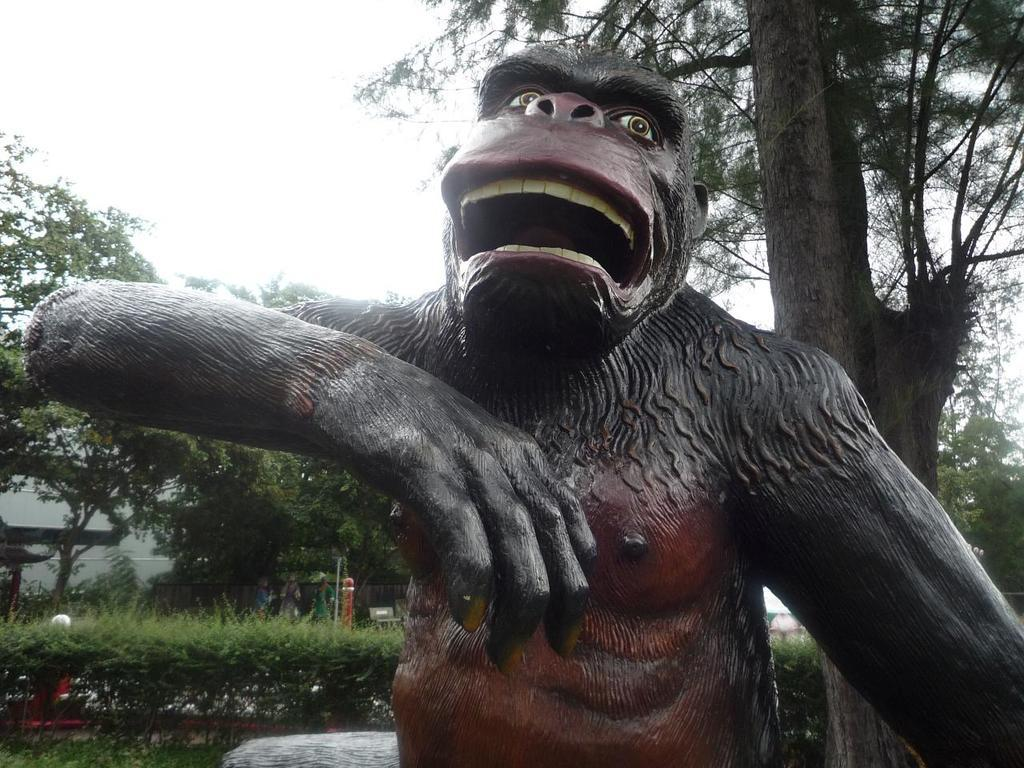What is the main subject in the front of the image? There is a statue in the front of the image. What type of vegetation can be seen in the background of the image? There are trees and shrubs in the background of the image. What is visible at the top of the image? The sky is visible at the top of the image. What type of tent can be seen in the image? There is no tent present in the image. What type of war is depicted in the image? There is no war depicted in the image; it features a statue and natural elements. 